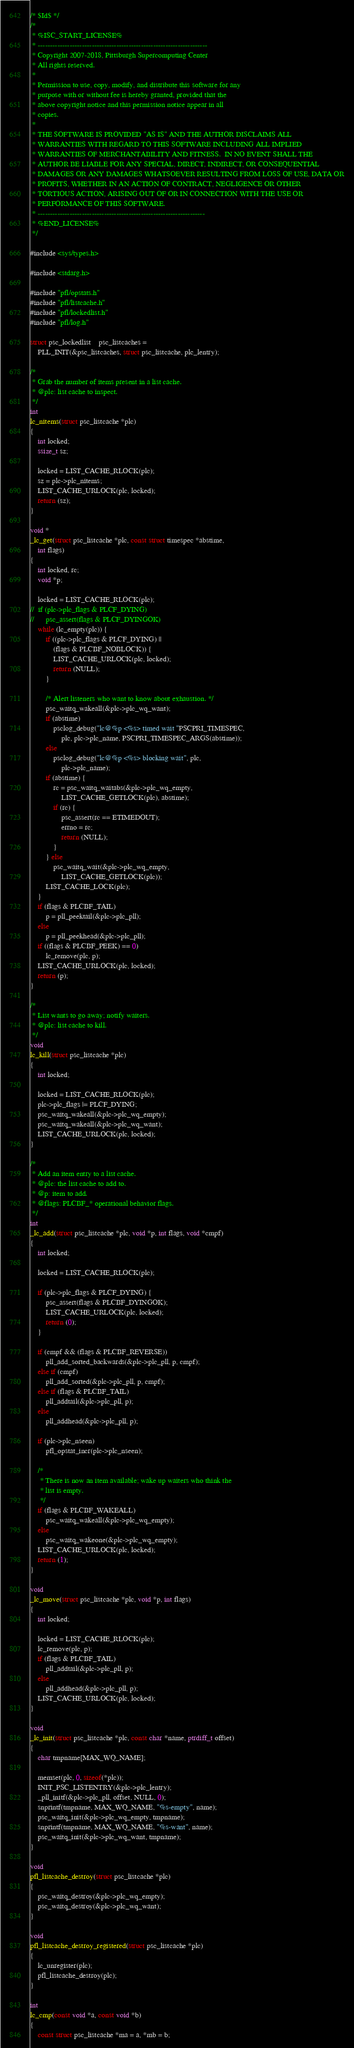<code> <loc_0><loc_0><loc_500><loc_500><_C_>/* $Id$ */
/*
 * %ISC_START_LICENSE%
 * ---------------------------------------------------------------------
 * Copyright 2007-2018, Pittsburgh Supercomputing Center
 * All rights reserved.
 *
 * Permission to use, copy, modify, and distribute this software for any
 * purpose with or without fee is hereby granted, provided that the
 * above copyright notice and this permission notice appear in all
 * copies.
 *
 * THE SOFTWARE IS PROVIDED "AS IS" AND THE AUTHOR DISCLAIMS ALL
 * WARRANTIES WITH REGARD TO THIS SOFTWARE INCLUDING ALL IMPLIED
 * WARRANTIES OF MERCHANTABILITY AND FITNESS.  IN NO EVENT SHALL THE
 * AUTHOR BE LIABLE FOR ANY SPECIAL, DIRECT, INDIRECT, OR CONSEQUENTIAL
 * DAMAGES OR ANY DAMAGES WHATSOEVER RESULTING FROM LOSS OF USE, DATA OR
 * PROFITS, WHETHER IN AN ACTION OF CONTRACT, NEGLIGENCE OR OTHER
 * TORTIOUS ACTION, ARISING OUT OF OR IN CONNECTION WITH THE USE OR
 * PERFORMANCE OF THIS SOFTWARE.
 * --------------------------------------------------------------------
 * %END_LICENSE%
 */

#include <sys/types.h>

#include <stdarg.h>

#include "pfl/opstats.h"
#include "pfl/listcache.h"
#include "pfl/lockedlist.h"
#include "pfl/log.h"

struct psc_lockedlist	psc_listcaches =
    PLL_INIT(&psc_listcaches, struct psc_listcache, plc_lentry);

/*
 * Grab the number of items present in a list cache.
 * @plc: list cache to inspect.
 */
int
lc_nitems(struct psc_listcache *plc)
{
	int locked;
	ssize_t sz;

	locked = LIST_CACHE_RLOCK(plc);
	sz = plc->plc_nitems;
	LIST_CACHE_URLOCK(plc, locked);
	return (sz);
}

void *
_lc_get(struct psc_listcache *plc, const struct timespec *abstime,
    int flags)
{
	int locked, rc;
	void *p;

	locked = LIST_CACHE_RLOCK(plc);
//	if (plc->plc_flags & PLCF_DYING)
//		psc_assert(flags & PLCF_DYINGOK)
	while (lc_empty(plc)) {
		if ((plc->plc_flags & PLCF_DYING) ||
		    (flags & PLCBF_NOBLOCK)) {
			LIST_CACHE_URLOCK(plc, locked);
			return (NULL);
		}

		/* Alert listeners who want to know about exhaustion. */
		psc_waitq_wakeall(&plc->plc_wq_want);
		if (abstime)
			psclog_debug("lc@%p <%s> timed wait "PSCPRI_TIMESPEC,
			    plc, plc->plc_name, PSCPRI_TIMESPEC_ARGS(abstime));
		else
			psclog_debug("lc@%p <%s> blocking wait", plc,
			    plc->plc_name);
		if (abstime) {
			rc = psc_waitq_waitabs(&plc->plc_wq_empty,
			    LIST_CACHE_GETLOCK(plc), abstime);
			if (rc) {
				psc_assert(rc == ETIMEDOUT);
				errno = rc;
				return (NULL);
			}
		} else
			psc_waitq_wait(&plc->plc_wq_empty,
			    LIST_CACHE_GETLOCK(plc));
		LIST_CACHE_LOCK(plc);
	}
	if (flags & PLCBF_TAIL)
		p = pll_peektail(&plc->plc_pll);
	else
		p = pll_peekhead(&plc->plc_pll);
	if ((flags & PLCBF_PEEK) == 0)
		lc_remove(plc, p);
	LIST_CACHE_URLOCK(plc, locked);
	return (p);
}

/*
 * List wants to go away; notify waiters.
 * @plc: list cache to kill.
 */
void
lc_kill(struct psc_listcache *plc)
{
	int locked;

	locked = LIST_CACHE_RLOCK(plc);
	plc->plc_flags |= PLCF_DYING;
	psc_waitq_wakeall(&plc->plc_wq_empty);
	psc_waitq_wakeall(&plc->plc_wq_want);
	LIST_CACHE_URLOCK(plc, locked);
}

/*
 * Add an item entry to a list cache.
 * @plc: the list cache to add to.
 * @p: item to add.
 * @flags: PLCBF_* operational behavior flags.
 */
int
_lc_add(struct psc_listcache *plc, void *p, int flags, void *cmpf)
{
	int locked;

	locked = LIST_CACHE_RLOCK(plc);

	if (plc->plc_flags & PLCF_DYING) {
		psc_assert(flags & PLCBF_DYINGOK);
		LIST_CACHE_URLOCK(plc, locked);
		return (0);
	}

	if (cmpf && (flags & PLCBF_REVERSE))
		pll_add_sorted_backwards(&plc->plc_pll, p, cmpf);
	else if (cmpf)
		pll_add_sorted(&plc->plc_pll, p, cmpf);
	else if (flags & PLCBF_TAIL)
		pll_addtail(&plc->plc_pll, p);
	else
		pll_addhead(&plc->plc_pll, p);

	if (plc->plc_nseen)
		pfl_opstat_incr(plc->plc_nseen);

	/*
	 * There is now an item available; wake up waiters who think the
	 * list is empty.
	 */
	if (flags & PLCBF_WAKEALL)
		psc_waitq_wakeall(&plc->plc_wq_empty);
	else
		psc_waitq_wakeone(&plc->plc_wq_empty);
	LIST_CACHE_URLOCK(plc, locked);
	return (1);
}

void
_lc_move(struct psc_listcache *plc, void *p, int flags)
{
	int locked;

	locked = LIST_CACHE_RLOCK(plc);
	lc_remove(plc, p);
	if (flags & PLCBF_TAIL)
		pll_addtail(&plc->plc_pll, p);
	else
		pll_addhead(&plc->plc_pll, p);
	LIST_CACHE_URLOCK(plc, locked);
}

void
_lc_init(struct psc_listcache *plc, const char *name, ptrdiff_t offset)
{
	char tmpname[MAX_WQ_NAME];

	memset(plc, 0, sizeof(*plc));
	INIT_PSC_LISTENTRY(&plc->plc_lentry);
	_pll_initf(&plc->plc_pll, offset, NULL, 0);
	snprintf(tmpname, MAX_WQ_NAME, "%s-empty", name);
	psc_waitq_init(&plc->plc_wq_empty, tmpname);
	snprintf(tmpname, MAX_WQ_NAME, "%s-want", name);
	psc_waitq_init(&plc->plc_wq_want, tmpname);
}

void
pfl_listcache_destroy(struct psc_listcache *plc)
{
	psc_waitq_destroy(&plc->plc_wq_empty);
	psc_waitq_destroy(&plc->plc_wq_want);
}

void
pfl_listcache_destroy_registered(struct psc_listcache *plc)
{
	lc_unregister(plc);
	pfl_listcache_destroy(plc);
}

int
lc_cmp(const void *a, const void *b)
{
	const struct psc_listcache *ma = a, *mb = b;
</code> 